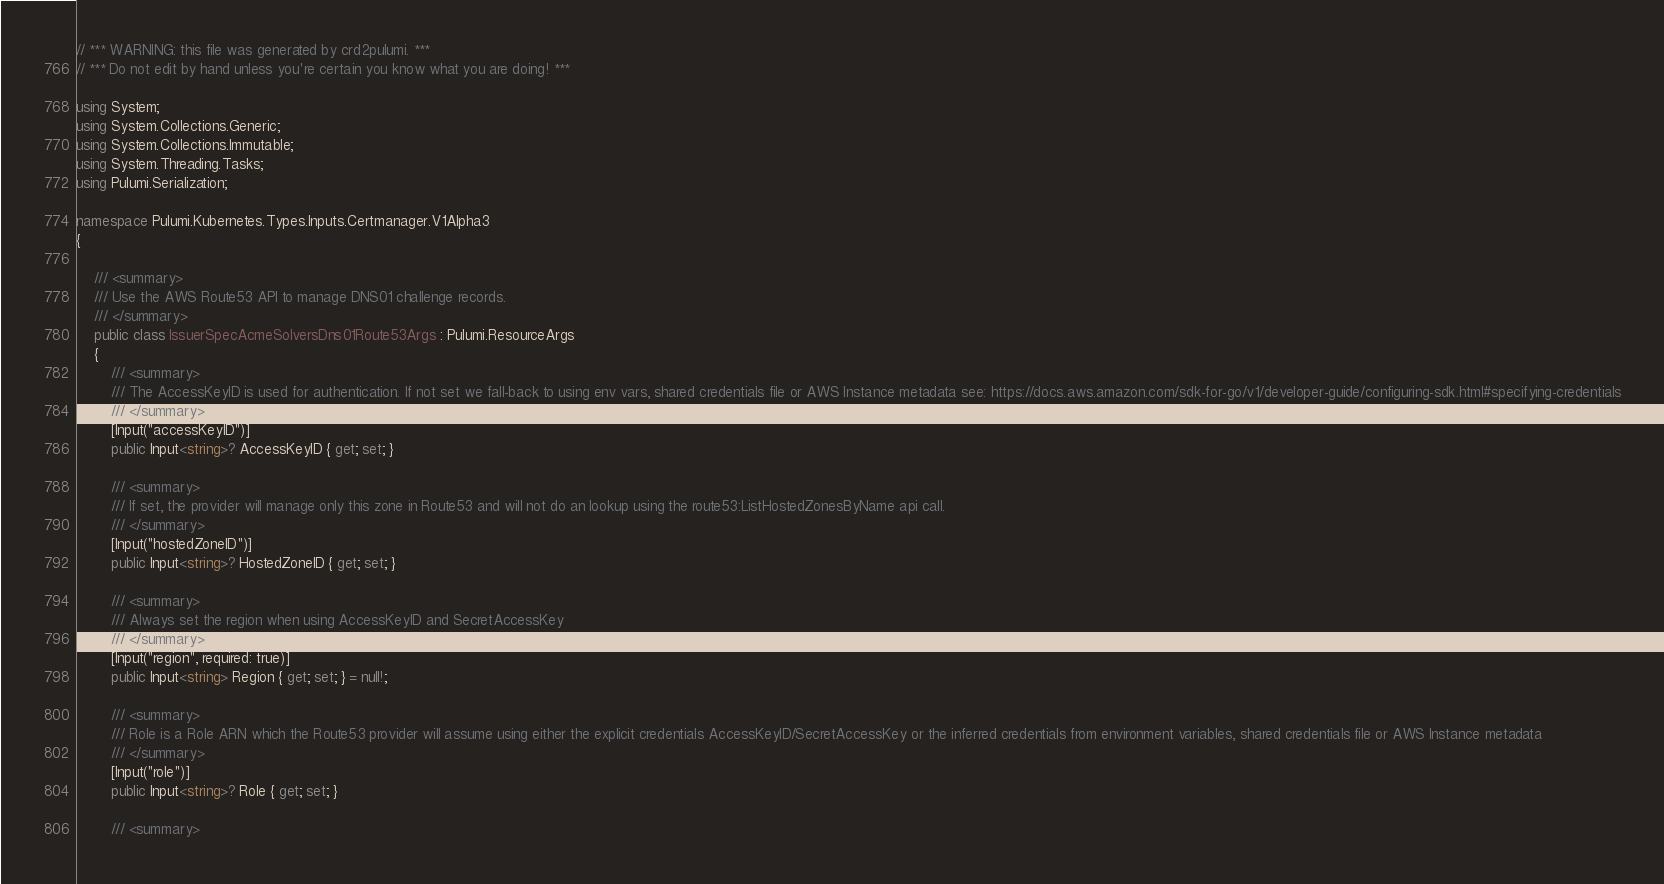<code> <loc_0><loc_0><loc_500><loc_500><_C#_>// *** WARNING: this file was generated by crd2pulumi. ***
// *** Do not edit by hand unless you're certain you know what you are doing! ***

using System;
using System.Collections.Generic;
using System.Collections.Immutable;
using System.Threading.Tasks;
using Pulumi.Serialization;

namespace Pulumi.Kubernetes.Types.Inputs.Certmanager.V1Alpha3
{

    /// <summary>
    /// Use the AWS Route53 API to manage DNS01 challenge records.
    /// </summary>
    public class IssuerSpecAcmeSolversDns01Route53Args : Pulumi.ResourceArgs
    {
        /// <summary>
        /// The AccessKeyID is used for authentication. If not set we fall-back to using env vars, shared credentials file or AWS Instance metadata see: https://docs.aws.amazon.com/sdk-for-go/v1/developer-guide/configuring-sdk.html#specifying-credentials
        /// </summary>
        [Input("accessKeyID")]
        public Input<string>? AccessKeyID { get; set; }

        /// <summary>
        /// If set, the provider will manage only this zone in Route53 and will not do an lookup using the route53:ListHostedZonesByName api call.
        /// </summary>
        [Input("hostedZoneID")]
        public Input<string>? HostedZoneID { get; set; }

        /// <summary>
        /// Always set the region when using AccessKeyID and SecretAccessKey
        /// </summary>
        [Input("region", required: true)]
        public Input<string> Region { get; set; } = null!;

        /// <summary>
        /// Role is a Role ARN which the Route53 provider will assume using either the explicit credentials AccessKeyID/SecretAccessKey or the inferred credentials from environment variables, shared credentials file or AWS Instance metadata
        /// </summary>
        [Input("role")]
        public Input<string>? Role { get; set; }

        /// <summary></code> 